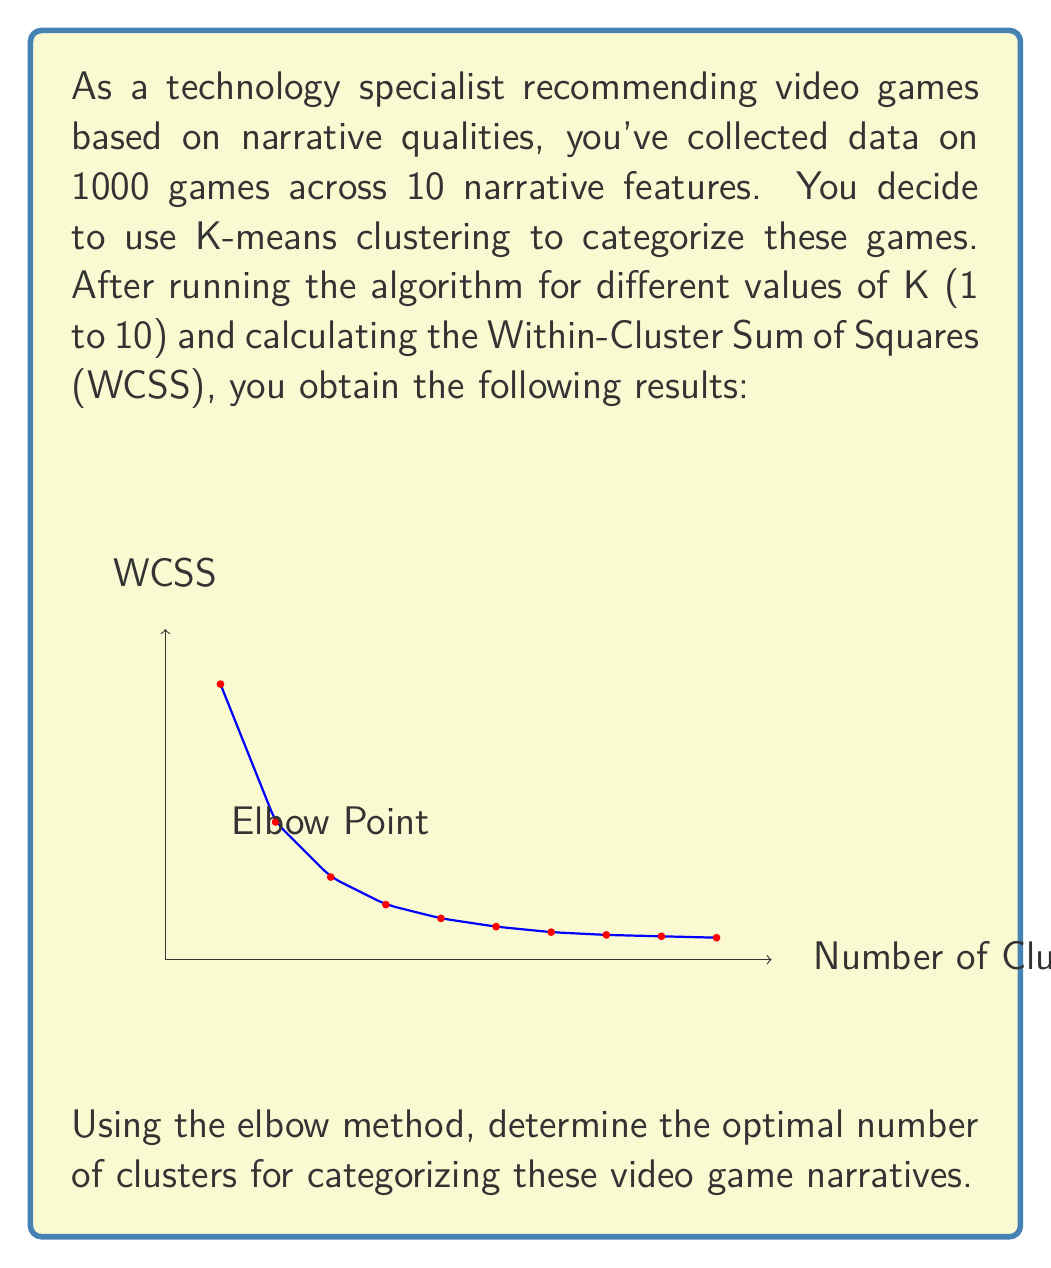Solve this math problem. To determine the optimal number of clusters using the elbow method, we need to follow these steps:

1. Observe the WCSS values as K increases:
   As K increases, WCSS generally decreases because each data point is closer to its assigned cluster center.

2. Identify the "elbow point":
   The elbow point is where the rate of decrease in WCSS begins to level off. After this point, increasing K provides diminishing returns.

3. Analyze the graph:
   Looking at the graph, we can see that the WCSS decreases rapidly from K=1 to K=3, but the rate of decrease slows significantly after K=3.

4. Locate the elbow:
   The elbow appears to be at K=3, where the graph begins to flatten out.

5. Interpret the result:
   K=3 represents the point where adding more clusters doesn't significantly reduce the WCSS. This suggests that 3 clusters provide a good balance between minimizing intra-cluster variation and avoiding overfitting.

Therefore, based on the elbow method, the optimal number of clusters for categorizing these video game narratives is 3.
Answer: 3 clusters 